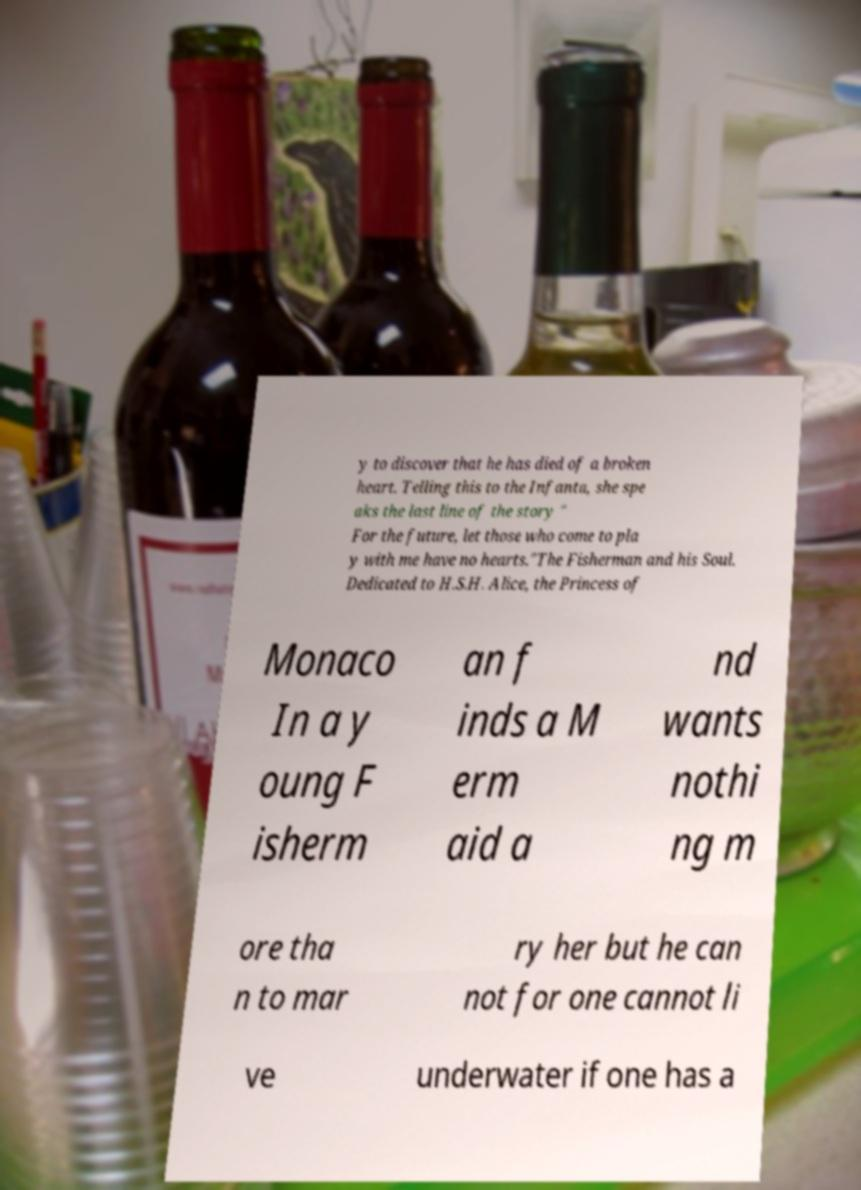There's text embedded in this image that I need extracted. Can you transcribe it verbatim? y to discover that he has died of a broken heart. Telling this to the Infanta, she spe aks the last line of the story " For the future, let those who come to pla y with me have no hearts."The Fisherman and his Soul. Dedicated to H.S.H. Alice, the Princess of Monaco In a y oung F isherm an f inds a M erm aid a nd wants nothi ng m ore tha n to mar ry her but he can not for one cannot li ve underwater if one has a 